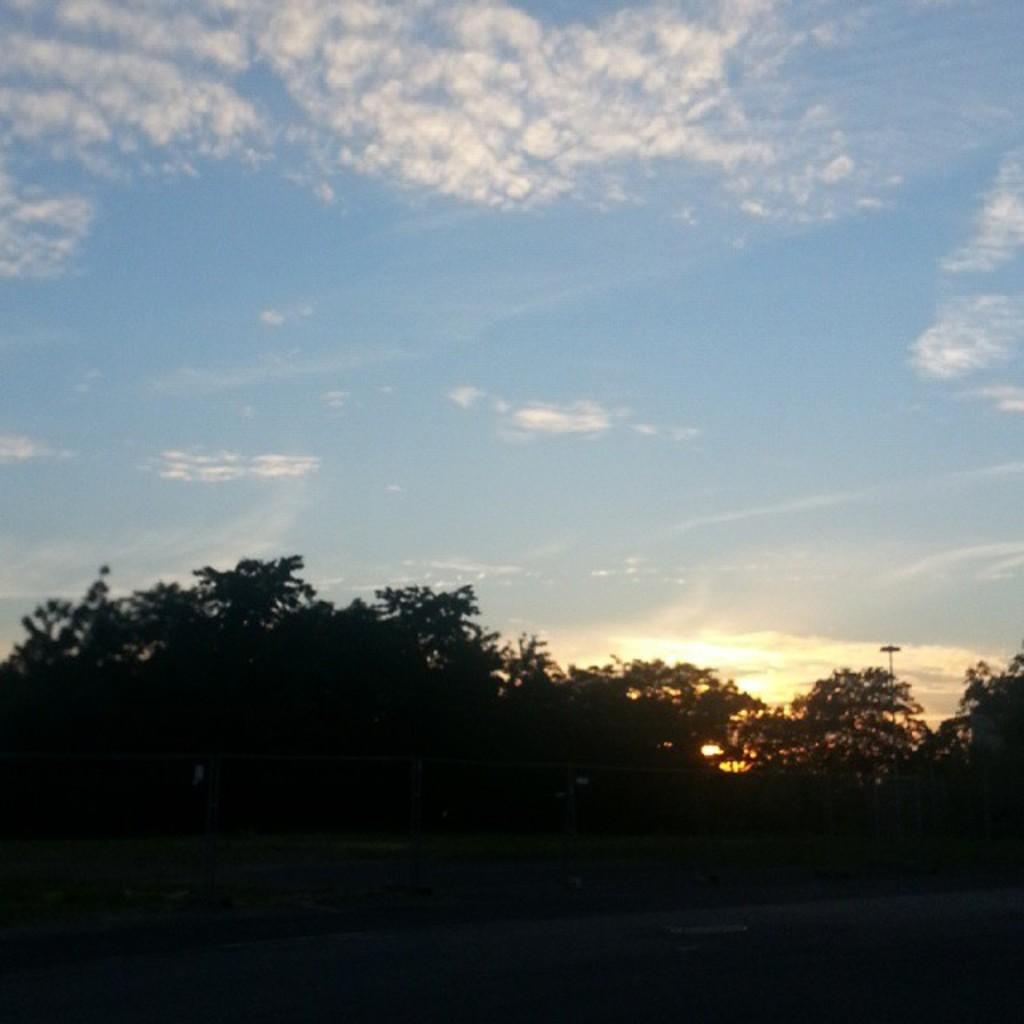Could you give a brief overview of what you see in this image? In this picture we can observe some trees. In the background there is a sky with some clouds. 